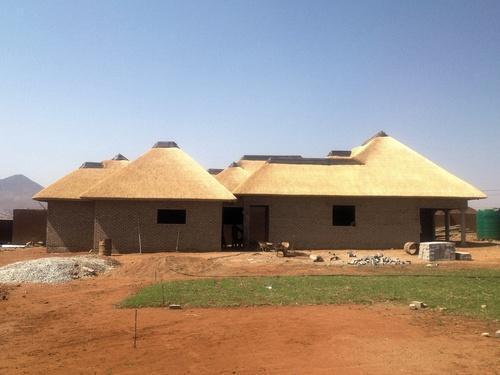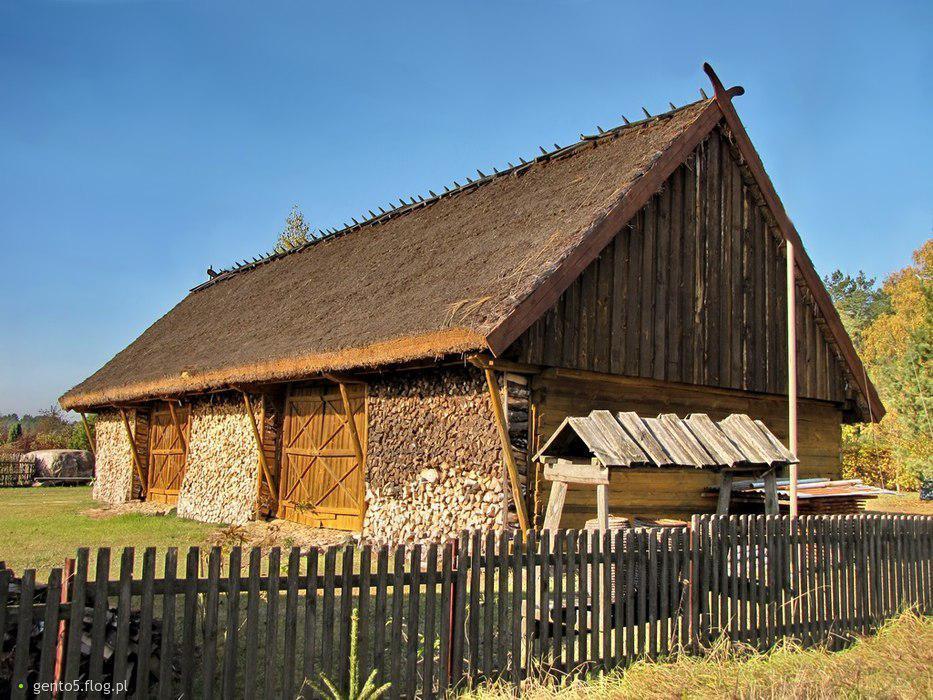The first image is the image on the left, the second image is the image on the right. Assess this claim about the two images: "Two buildings have second story windows.". Correct or not? Answer yes or no. No. The first image is the image on the left, the second image is the image on the right. Assess this claim about the two images: "The building in the image on the right is fenced in.". Correct or not? Answer yes or no. Yes. 